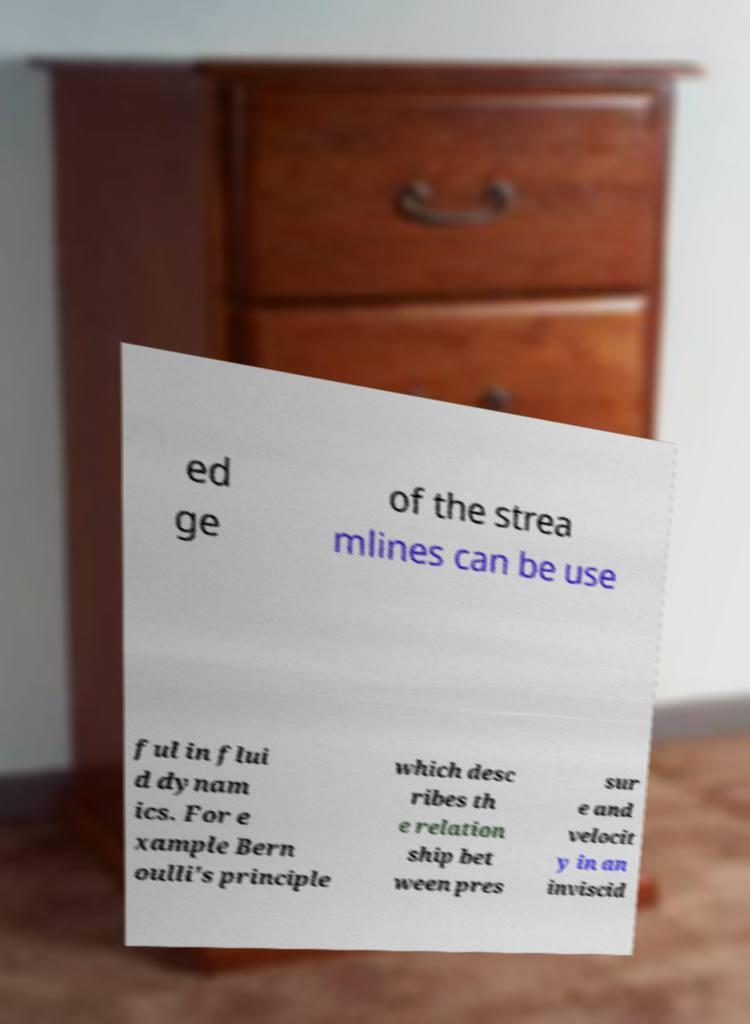Can you read and provide the text displayed in the image?This photo seems to have some interesting text. Can you extract and type it out for me? ed ge of the strea mlines can be use ful in flui d dynam ics. For e xample Bern oulli's principle which desc ribes th e relation ship bet ween pres sur e and velocit y in an inviscid 